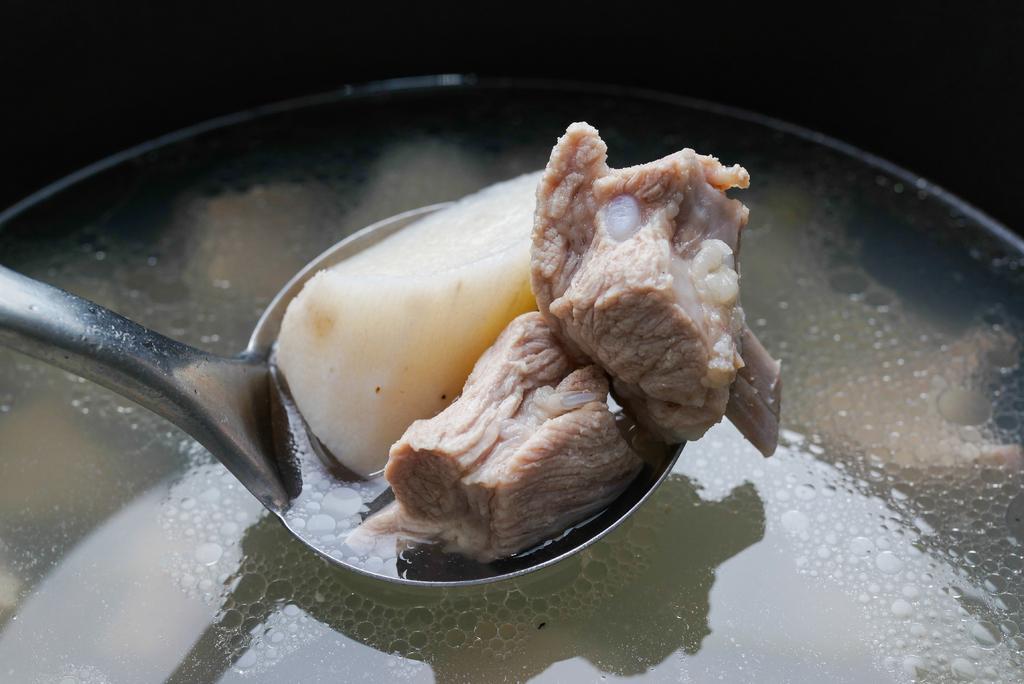Can you describe this image briefly? In this picture we can see a spoon, meat, liquid and in the background it is dark. 